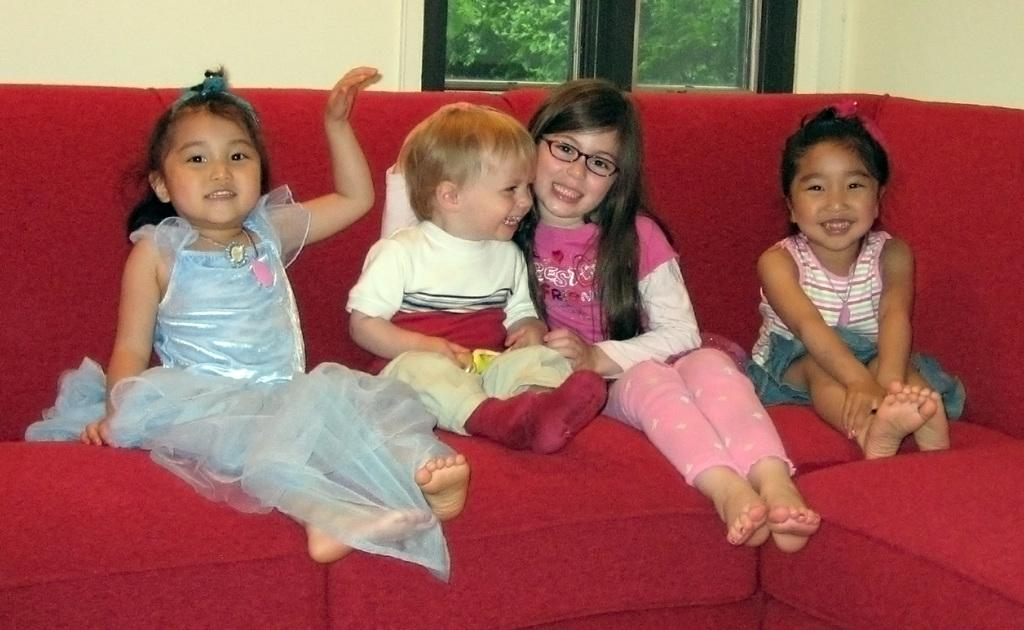Who is present in the image? There are children in the image. What are the children sitting on? The children are sitting on a red colored couch. What color is the wall behind the couch? There is a cream colored wall in the image. What can be seen through the window in the image? Trees are visible through the window. What type of disease is affecting the children in the image? There is no indication of any disease affecting the children in the image. Can you describe the waves visible in the image? There are no waves visible in the image; it features children sitting on a couch with a window showing trees. 